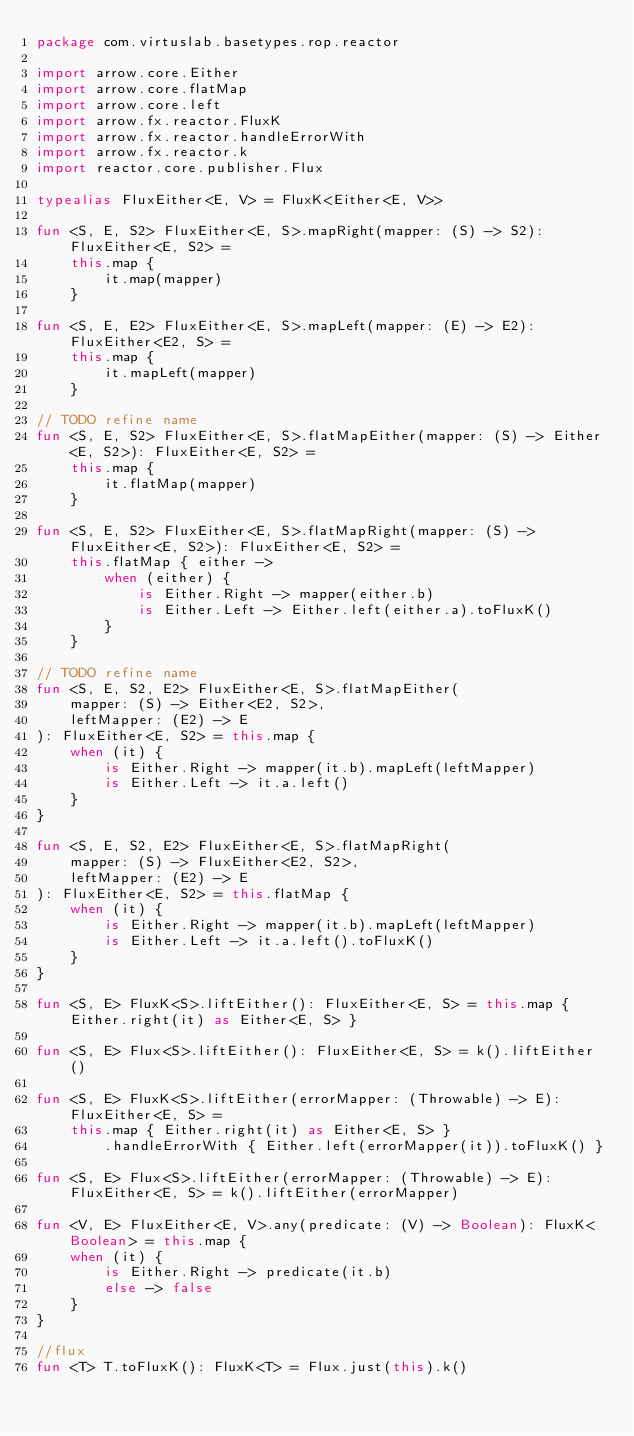Convert code to text. <code><loc_0><loc_0><loc_500><loc_500><_Kotlin_>package com.virtuslab.basetypes.rop.reactor

import arrow.core.Either
import arrow.core.flatMap
import arrow.core.left
import arrow.fx.reactor.FluxK
import arrow.fx.reactor.handleErrorWith
import arrow.fx.reactor.k
import reactor.core.publisher.Flux

typealias FluxEither<E, V> = FluxK<Either<E, V>>

fun <S, E, S2> FluxEither<E, S>.mapRight(mapper: (S) -> S2): FluxEither<E, S2> =
    this.map {
        it.map(mapper)
    }

fun <S, E, E2> FluxEither<E, S>.mapLeft(mapper: (E) -> E2): FluxEither<E2, S> =
    this.map {
        it.mapLeft(mapper)
    }

// TODO refine name
fun <S, E, S2> FluxEither<E, S>.flatMapEither(mapper: (S) -> Either<E, S2>): FluxEither<E, S2> =
    this.map {
        it.flatMap(mapper)
    }

fun <S, E, S2> FluxEither<E, S>.flatMapRight(mapper: (S) -> FluxEither<E, S2>): FluxEither<E, S2> =
    this.flatMap { either ->
        when (either) {
            is Either.Right -> mapper(either.b)
            is Either.Left -> Either.left(either.a).toFluxK()
        }
    }

// TODO refine name
fun <S, E, S2, E2> FluxEither<E, S>.flatMapEither(
    mapper: (S) -> Either<E2, S2>,
    leftMapper: (E2) -> E
): FluxEither<E, S2> = this.map {
    when (it) {
        is Either.Right -> mapper(it.b).mapLeft(leftMapper)
        is Either.Left -> it.a.left()
    }
}

fun <S, E, S2, E2> FluxEither<E, S>.flatMapRight(
    mapper: (S) -> FluxEither<E2, S2>,
    leftMapper: (E2) -> E
): FluxEither<E, S2> = this.flatMap {
    when (it) {
        is Either.Right -> mapper(it.b).mapLeft(leftMapper)
        is Either.Left -> it.a.left().toFluxK()
    }
}

fun <S, E> FluxK<S>.liftEither(): FluxEither<E, S> = this.map { Either.right(it) as Either<E, S> }

fun <S, E> Flux<S>.liftEither(): FluxEither<E, S> = k().liftEither()

fun <S, E> FluxK<S>.liftEither(errorMapper: (Throwable) -> E): FluxEither<E, S> =
    this.map { Either.right(it) as Either<E, S> }
        .handleErrorWith { Either.left(errorMapper(it)).toFluxK() }

fun <S, E> Flux<S>.liftEither(errorMapper: (Throwable) -> E): FluxEither<E, S> = k().liftEither(errorMapper)

fun <V, E> FluxEither<E, V>.any(predicate: (V) -> Boolean): FluxK<Boolean> = this.map {
    when (it) {
        is Either.Right -> predicate(it.b)
        else -> false
    }
}

//flux
fun <T> T.toFluxK(): FluxK<T> = Flux.just(this).k()</code> 